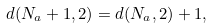<formula> <loc_0><loc_0><loc_500><loc_500>d ( N _ { a } + 1 , 2 ) = d ( N _ { a } , 2 ) + 1 ,</formula> 